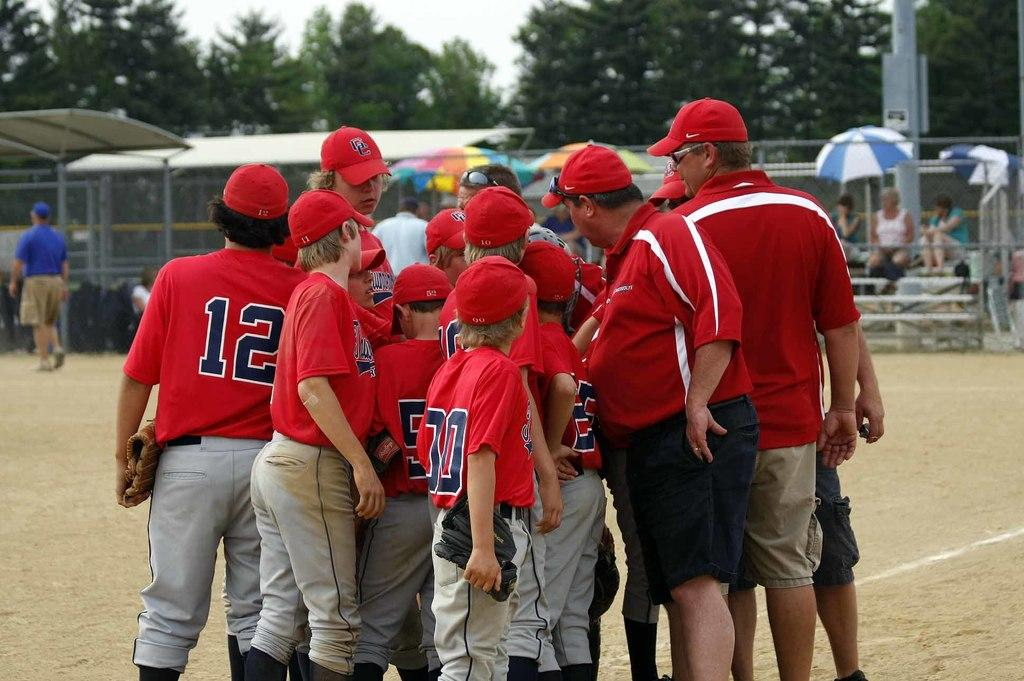<image>
Render a clear and concise summary of the photo. a player with the number 12 huddled with others 